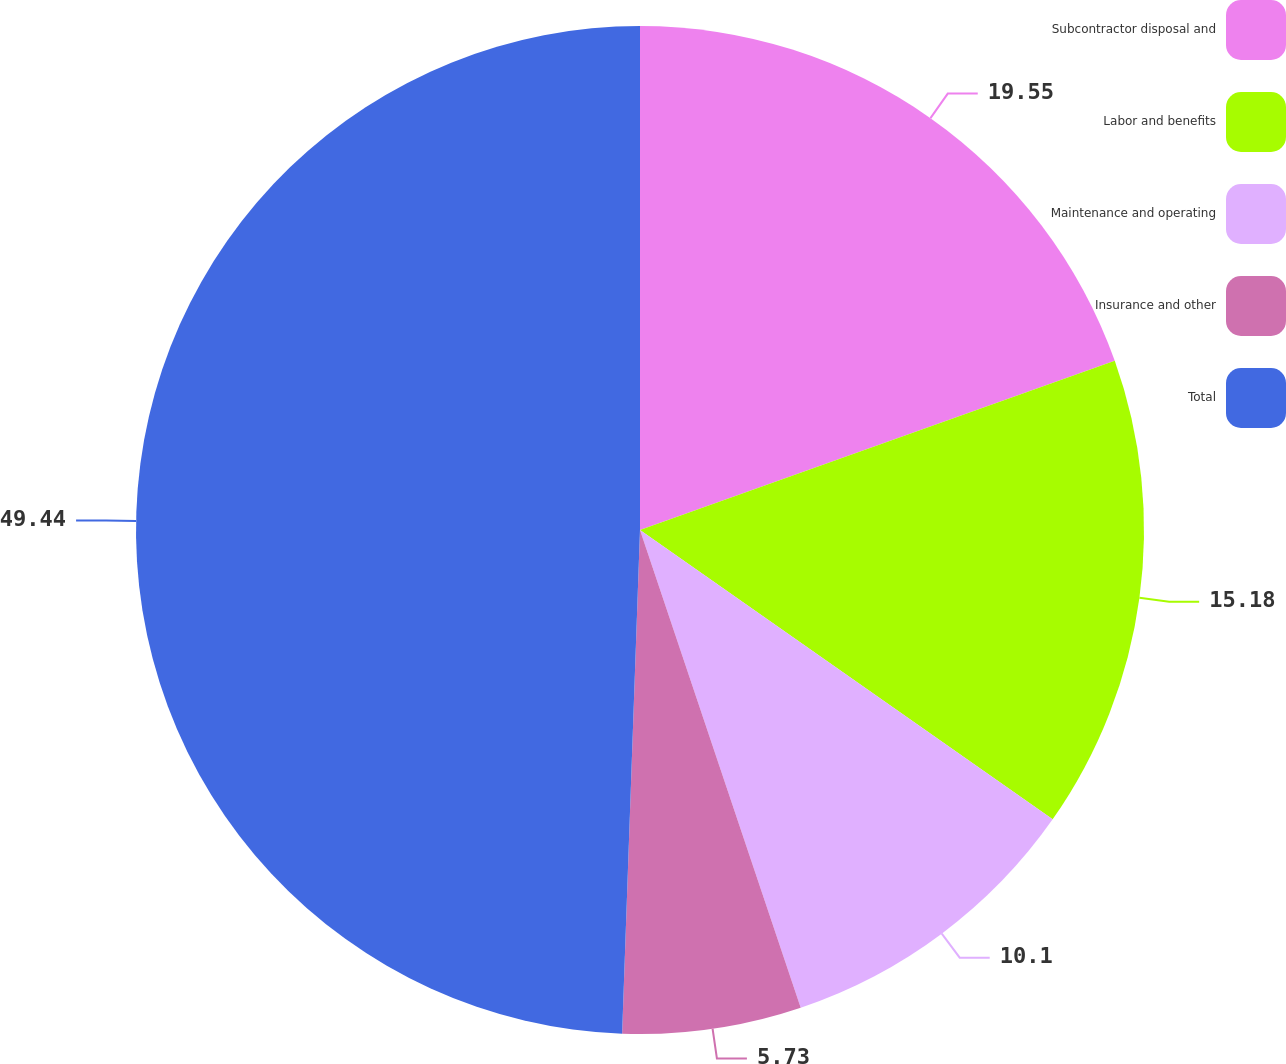<chart> <loc_0><loc_0><loc_500><loc_500><pie_chart><fcel>Subcontractor disposal and<fcel>Labor and benefits<fcel>Maintenance and operating<fcel>Insurance and other<fcel>Total<nl><fcel>19.55%<fcel>15.18%<fcel>10.1%<fcel>5.73%<fcel>49.43%<nl></chart> 